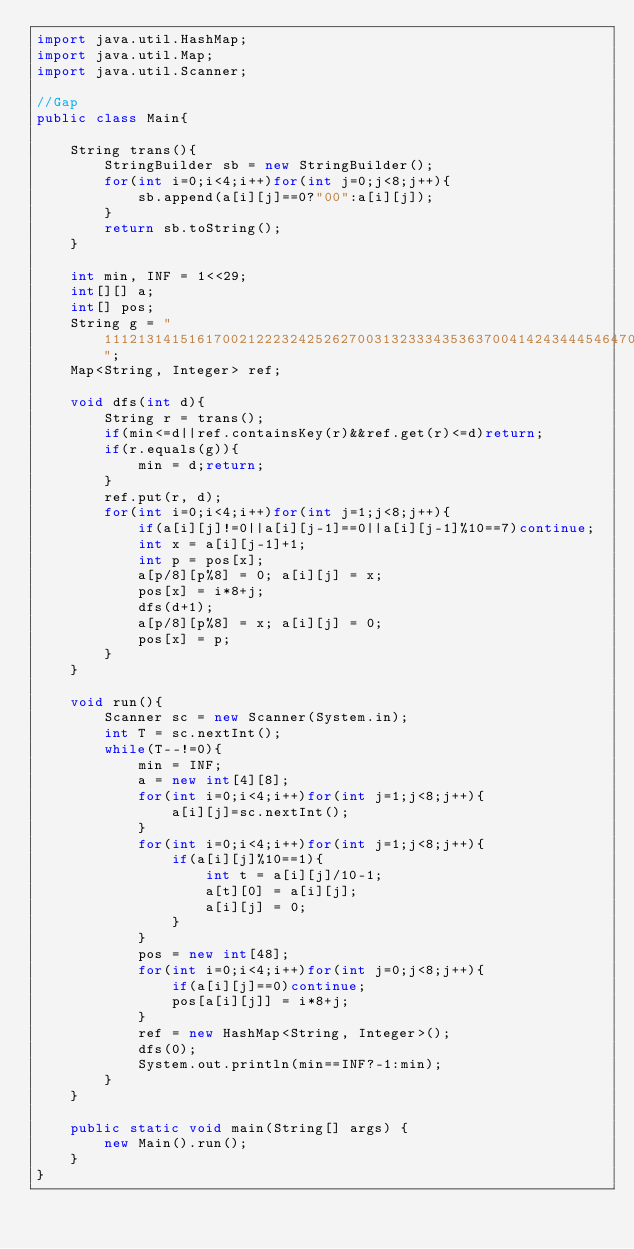Convert code to text. <code><loc_0><loc_0><loc_500><loc_500><_Java_>import java.util.HashMap;
import java.util.Map;
import java.util.Scanner;

//Gap
public class Main{

	String trans(){
		StringBuilder sb = new StringBuilder();
		for(int i=0;i<4;i++)for(int j=0;j<8;j++){
			sb.append(a[i][j]==0?"00":a[i][j]);
		}
		return sb.toString();
	}
	
	int min, INF = 1<<29;
	int[][] a;
	int[] pos;
	String g = "1112131415161700212223242526270031323334353637004142434445464700";
	Map<String, Integer> ref;
	
	void dfs(int d){
		String r = trans();
		if(min<=d||ref.containsKey(r)&&ref.get(r)<=d)return;
		if(r.equals(g)){
			min = d;return;
		}
		ref.put(r, d);
		for(int i=0;i<4;i++)for(int j=1;j<8;j++){
			if(a[i][j]!=0||a[i][j-1]==0||a[i][j-1]%10==7)continue;
			int x = a[i][j-1]+1;
			int p = pos[x];
			a[p/8][p%8] = 0; a[i][j] = x;
			pos[x] = i*8+j;
			dfs(d+1);
			a[p/8][p%8] = x; a[i][j] = 0;
			pos[x] = p;
		}
	}
	
	void run(){
		Scanner sc = new Scanner(System.in);
		int T = sc.nextInt();
		while(T--!=0){
			min = INF;
			a = new int[4][8];
			for(int i=0;i<4;i++)for(int j=1;j<8;j++){
				a[i][j]=sc.nextInt();
			}
			for(int i=0;i<4;i++)for(int j=1;j<8;j++){
				if(a[i][j]%10==1){
					int t = a[i][j]/10-1;
					a[t][0] = a[i][j];
					a[i][j] = 0;
				}
			}
			pos = new int[48];
			for(int i=0;i<4;i++)for(int j=0;j<8;j++){
				if(a[i][j]==0)continue;
				pos[a[i][j]] = i*8+j;
			}
			ref = new HashMap<String, Integer>();
			dfs(0);
			System.out.println(min==INF?-1:min);
		}
	}
	
	public static void main(String[] args) {
		new Main().run();
	}
}</code> 